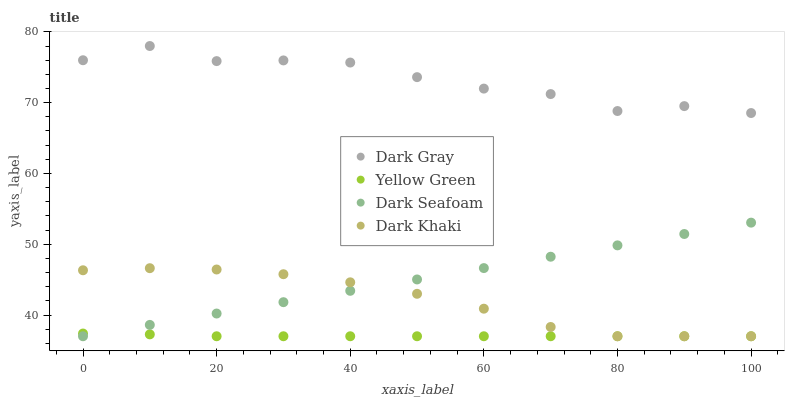Does Yellow Green have the minimum area under the curve?
Answer yes or no. Yes. Does Dark Gray have the maximum area under the curve?
Answer yes or no. Yes. Does Dark Khaki have the minimum area under the curve?
Answer yes or no. No. Does Dark Khaki have the maximum area under the curve?
Answer yes or no. No. Is Dark Seafoam the smoothest?
Answer yes or no. Yes. Is Dark Gray the roughest?
Answer yes or no. Yes. Is Dark Khaki the smoothest?
Answer yes or no. No. Is Dark Khaki the roughest?
Answer yes or no. No. Does Dark Khaki have the lowest value?
Answer yes or no. Yes. Does Dark Gray have the highest value?
Answer yes or no. Yes. Does Dark Khaki have the highest value?
Answer yes or no. No. Is Dark Seafoam less than Dark Gray?
Answer yes or no. Yes. Is Dark Gray greater than Dark Khaki?
Answer yes or no. Yes. Does Yellow Green intersect Dark Seafoam?
Answer yes or no. Yes. Is Yellow Green less than Dark Seafoam?
Answer yes or no. No. Is Yellow Green greater than Dark Seafoam?
Answer yes or no. No. Does Dark Seafoam intersect Dark Gray?
Answer yes or no. No. 